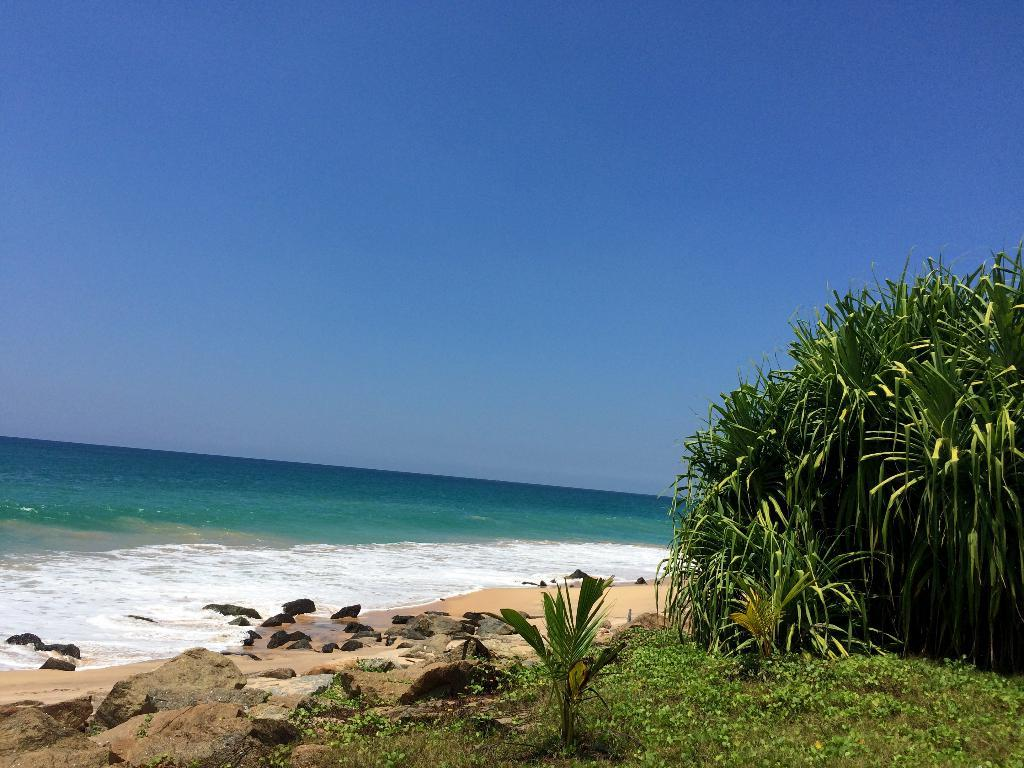What can be seen in the sky in the image? The sky is visible in the image. What type of large body of water is present in the image? There is an ocean in the image. What type of natural materials are present in the image? Stones, rocks, sand, plants, and bushes are visible in the image. How many spiders are crawling on the edge of the appliance in the image? There are no spiders or appliances present in the image. 